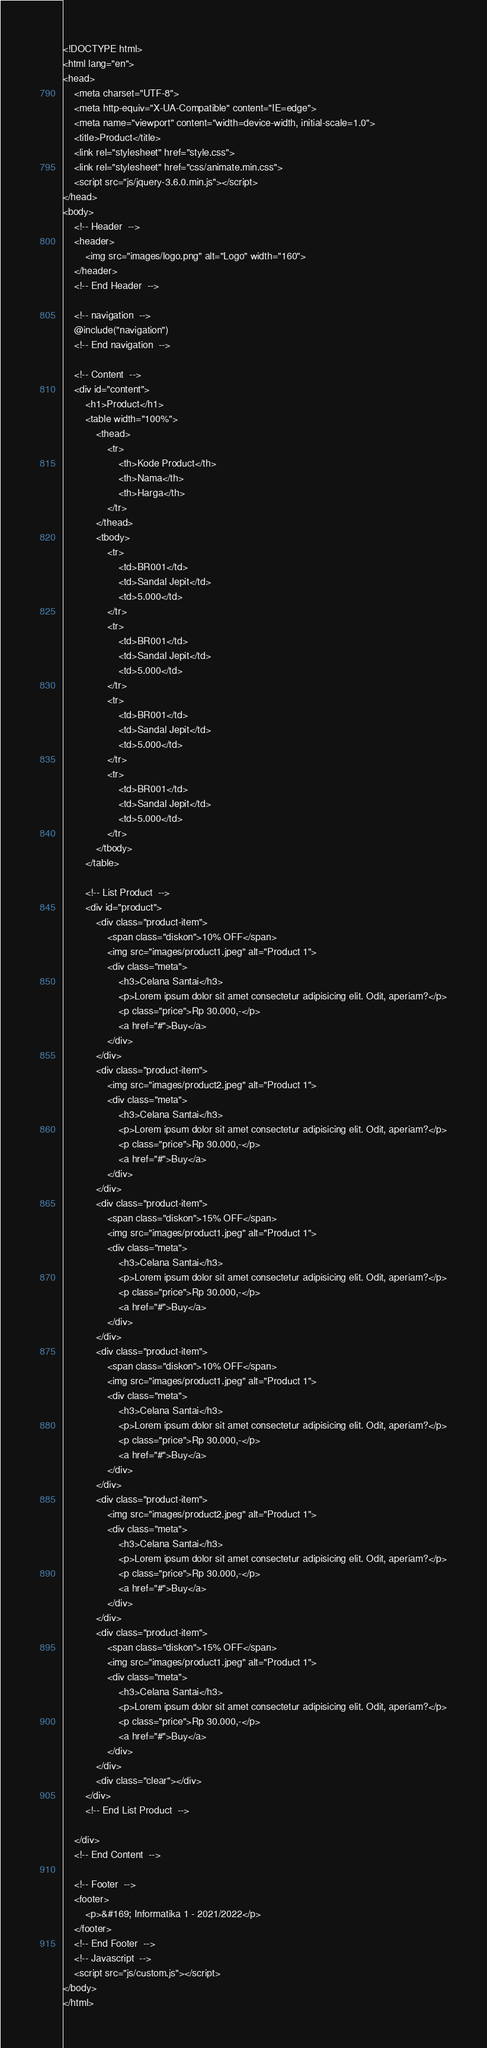Convert code to text. <code><loc_0><loc_0><loc_500><loc_500><_PHP_><!DOCTYPE html>
<html lang="en">
<head>
    <meta charset="UTF-8">
    <meta http-equiv="X-UA-Compatible" content="IE=edge">
    <meta name="viewport" content="width=device-width, initial-scale=1.0">
    <title>Product</title>
    <link rel="stylesheet" href="style.css">
    <link rel="stylesheet" href="css/animate.min.css">
    <script src="js/jquery-3.6.0.min.js"></script>
</head>
<body>    
    <!-- Header  -->
    <header>
        <img src="images/logo.png" alt="Logo" width="160">
    </header>
    <!-- End Header  -->

    <!-- navigation  -->
    @include("navigation")
    <!-- End navigation  -->

    <!-- Content  -->
    <div id="content">
        <h1>Product</h1>
        <table width="100%">
            <thead>
                <tr>
                    <th>Kode Product</th>
                    <th>Nama</th>
                    <th>Harga</th>
                </tr>
            </thead>
            <tbody>
                <tr>
                    <td>BR001</td>
                    <td>Sandal Jepit</td>
                    <td>5.000</td>
                </tr>
                <tr>
                    <td>BR001</td>
                    <td>Sandal Jepit</td>
                    <td>5.000</td>
                </tr>
                <tr>
                    <td>BR001</td>
                    <td>Sandal Jepit</td>
                    <td>5.000</td>
                </tr>
                <tr>
                    <td>BR001</td>
                    <td>Sandal Jepit</td>
                    <td>5.000</td>
                </tr>
            </tbody>
        </table>

        <!-- List Product  -->
        <div id="product">
            <div class="product-item">
                <span class="diskon">10% OFF</span>
                <img src="images/product1.jpeg" alt="Product 1">
                <div class="meta">
                    <h3>Celana Santai</h3>
                    <p>Lorem ipsum dolor sit amet consectetur adipisicing elit. Odit, aperiam?</p>
                    <p class="price">Rp 30.000,-</p>
                    <a href="#">Buy</a>
                </div>
            </div>
            <div class="product-item">
                <img src="images/product2.jpeg" alt="Product 1">
                <div class="meta">
                    <h3>Celana Santai</h3>
                    <p>Lorem ipsum dolor sit amet consectetur adipisicing elit. Odit, aperiam?</p>
                    <p class="price">Rp 30.000,-</p>
                    <a href="#">Buy</a>
                </div>
            </div>
            <div class="product-item">
                <span class="diskon">15% OFF</span>
                <img src="images/product1.jpeg" alt="Product 1">
                <div class="meta">
                    <h3>Celana Santai</h3>
                    <p>Lorem ipsum dolor sit amet consectetur adipisicing elit. Odit, aperiam?</p>
                    <p class="price">Rp 30.000,-</p>
                    <a href="#">Buy</a>
                </div>
            </div>
            <div class="product-item">
                <span class="diskon">10% OFF</span>
                <img src="images/product1.jpeg" alt="Product 1">
                <div class="meta">
                    <h3>Celana Santai</h3>
                    <p>Lorem ipsum dolor sit amet consectetur adipisicing elit. Odit, aperiam?</p>
                    <p class="price">Rp 30.000,-</p>
                    <a href="#">Buy</a>
                </div>
            </div>
            <div class="product-item">
                <img src="images/product2.jpeg" alt="Product 1">
                <div class="meta">
                    <h3>Celana Santai</h3>
                    <p>Lorem ipsum dolor sit amet consectetur adipisicing elit. Odit, aperiam?</p>
                    <p class="price">Rp 30.000,-</p>
                    <a href="#">Buy</a>
                </div>
            </div>
            <div class="product-item">
                <span class="diskon">15% OFF</span>
                <img src="images/product1.jpeg" alt="Product 1">
                <div class="meta">
                    <h3>Celana Santai</h3>
                    <p>Lorem ipsum dolor sit amet consectetur adipisicing elit. Odit, aperiam?</p>
                    <p class="price">Rp 30.000,-</p>
                    <a href="#">Buy</a>
                </div>
            </div>                                       
            <div class="clear"></div>
        </div>
        <!-- End List Product  -->

    </div>
    <!-- End Content  -->

    <!-- Footer  -->
    <footer>
        <p>&#169; Informatika 1 - 2021/2022</p>
    </footer>
    <!-- End Footer  -->
    <!-- Javascript  -->    
    <script src="js/custom.js"></script>
</body>
</html></code> 